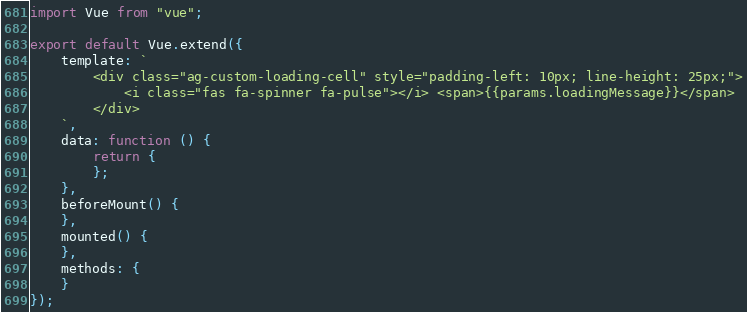Convert code to text. <code><loc_0><loc_0><loc_500><loc_500><_JavaScript_>import Vue from "vue";

export default Vue.extend({
    template: `
        <div class="ag-custom-loading-cell" style="padding-left: 10px; line-height: 25px;">
            <i class="fas fa-spinner fa-pulse"></i> <span>{{params.loadingMessage}}</span>
        </div>
    `,
    data: function () {
        return {
        };
    },
    beforeMount() {
    },
    mounted() {
    },
    methods: {
    }
});</code> 